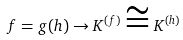<formula> <loc_0><loc_0><loc_500><loc_500>f = g ( h ) \rightarrow K ^ { ( f ) } \cong K ^ { ( h ) }</formula> 